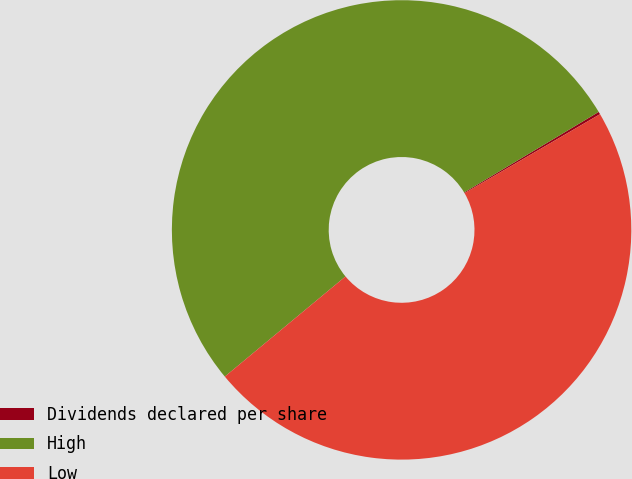Convert chart to OTSL. <chart><loc_0><loc_0><loc_500><loc_500><pie_chart><fcel>Dividends declared per share<fcel>High<fcel>Low<nl><fcel>0.18%<fcel>52.44%<fcel>47.38%<nl></chart> 